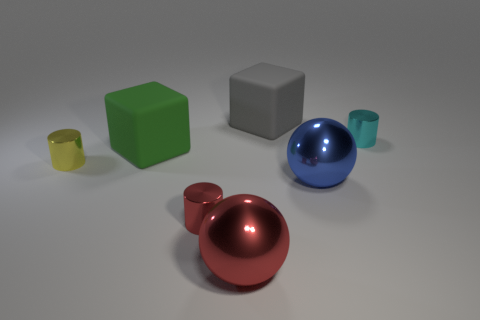Is the number of gray matte objects greater than the number of tiny cylinders?
Your answer should be very brief. No. How many metal cylinders are both to the right of the tiny yellow object and in front of the tiny cyan metallic cylinder?
Make the answer very short. 1. There is a large matte thing behind the cube in front of the big thing that is behind the large green matte block; what shape is it?
Your answer should be very brief. Cube. What number of cylinders are either small things or small cyan things?
Provide a succinct answer. 3. There is a block that is left of the big matte thing on the right side of the metallic ball in front of the blue metal sphere; what is its material?
Give a very brief answer. Rubber. Do the red shiny cylinder and the gray block have the same size?
Your answer should be compact. No. What shape is the large blue object that is made of the same material as the small cyan cylinder?
Make the answer very short. Sphere. There is a large green thing behind the tiny yellow cylinder; is it the same shape as the large gray rubber object?
Provide a succinct answer. Yes. There is a shiny cylinder that is behind the yellow metallic cylinder that is on the left side of the big gray block; what is its size?
Your answer should be compact. Small. What is the color of the other large sphere that is made of the same material as the big blue sphere?
Your answer should be compact. Red. 